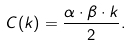<formula> <loc_0><loc_0><loc_500><loc_500>C ( k ) = \frac { \alpha \cdot \beta \cdot k } { 2 } .</formula> 